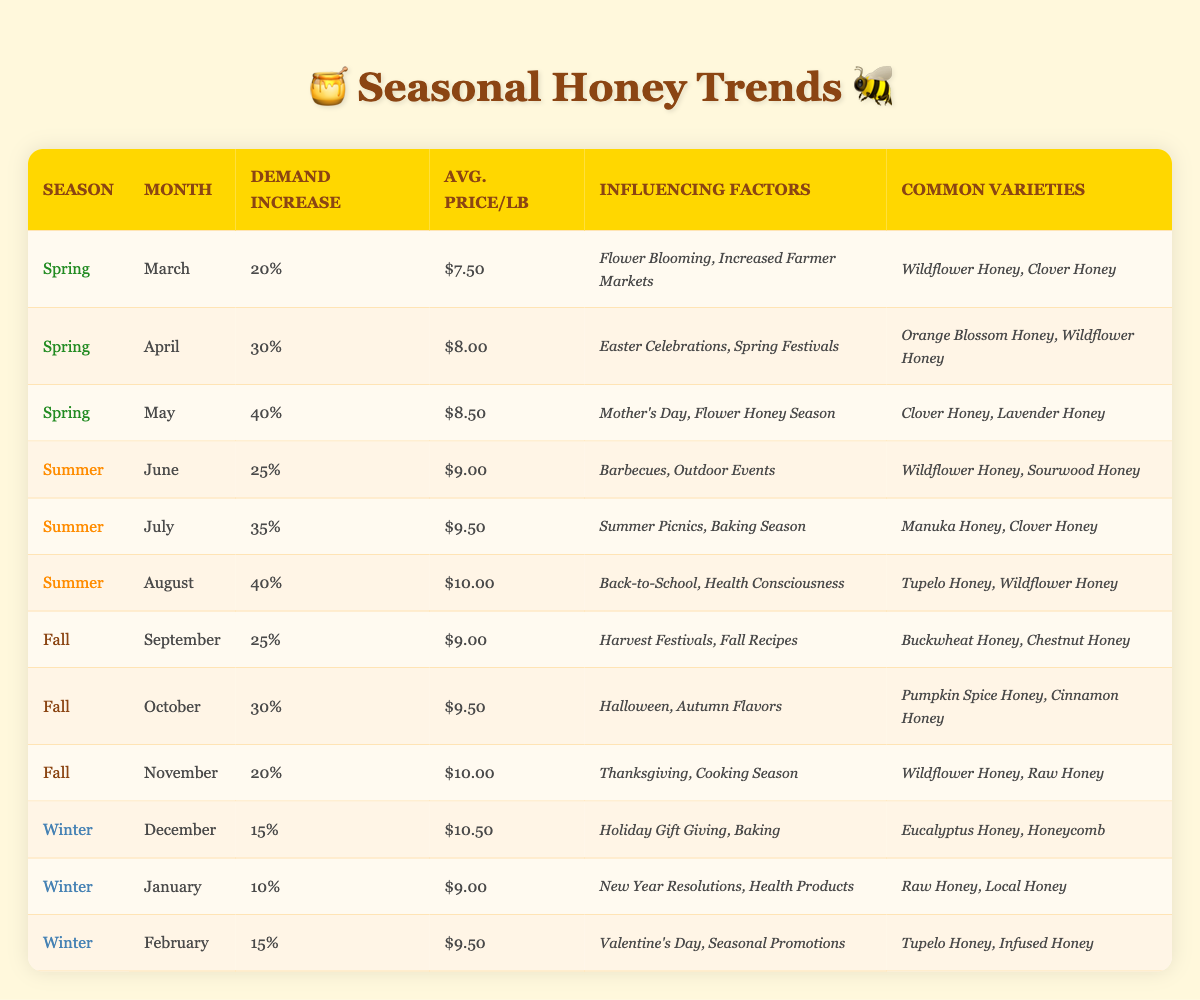What is the average price per pound of honey in August? Looking at the table, the average price per pound of honey in August is listed as $10.00.
Answer: $10.00 Which month in Spring has the highest demand increase percentage? Examining the Spring months, March has a demand increase of 20%, April has 30%, and May has 40%. The highest is in May.
Answer: May In which season is the average price per pound of honey the highest, based on the table? The prices in each season are: Spring: $8.50 (May), Summer: $10.00 (August), Fall: $10.00 (November), Winter: $10.50 (December). The highest is Winter.
Answer: Winter Is there a month in Winter where the demand increase percentage is higher than 15%? The demand increase percentages for Winter months are: December (15%), January (10%), and February (15%). None exceed 15%.
Answer: No What is the combined demand increase percentage for the months of Spring? The demand increase percentages for Spring are: March (20%), April (30%), and May (40). Summing these gives 20 + 30 + 40 = 90. Therefore, the total is 90%.
Answer: 90% Which common honey variety is present in both June and August? Looking at the common varieties in June (Wildflower Honey, Sourwood Honey) and August (Tupelo Honey, Wildflower Honey), the common variety is Wildflower Honey.
Answer: Wildflower Honey During which month does honey seek to appeal particularly for Mother's Day? The table specifies that Mother's Day influences demand in May, where the demand increase is particularly high at 40%.
Answer: May Is Clover Honey a common variety in both Spring and Summer months? Upon checking, Clover Honey appears in Spring (March, May) and Summer (July). Therefore, the answer is yes.
Answer: Yes 